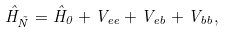Convert formula to latex. <formula><loc_0><loc_0><loc_500><loc_500>\hat { H } _ { \tilde { N } } = \hat { H } _ { 0 } + V _ { e e } + V _ { e b } + V _ { b b } ,</formula> 